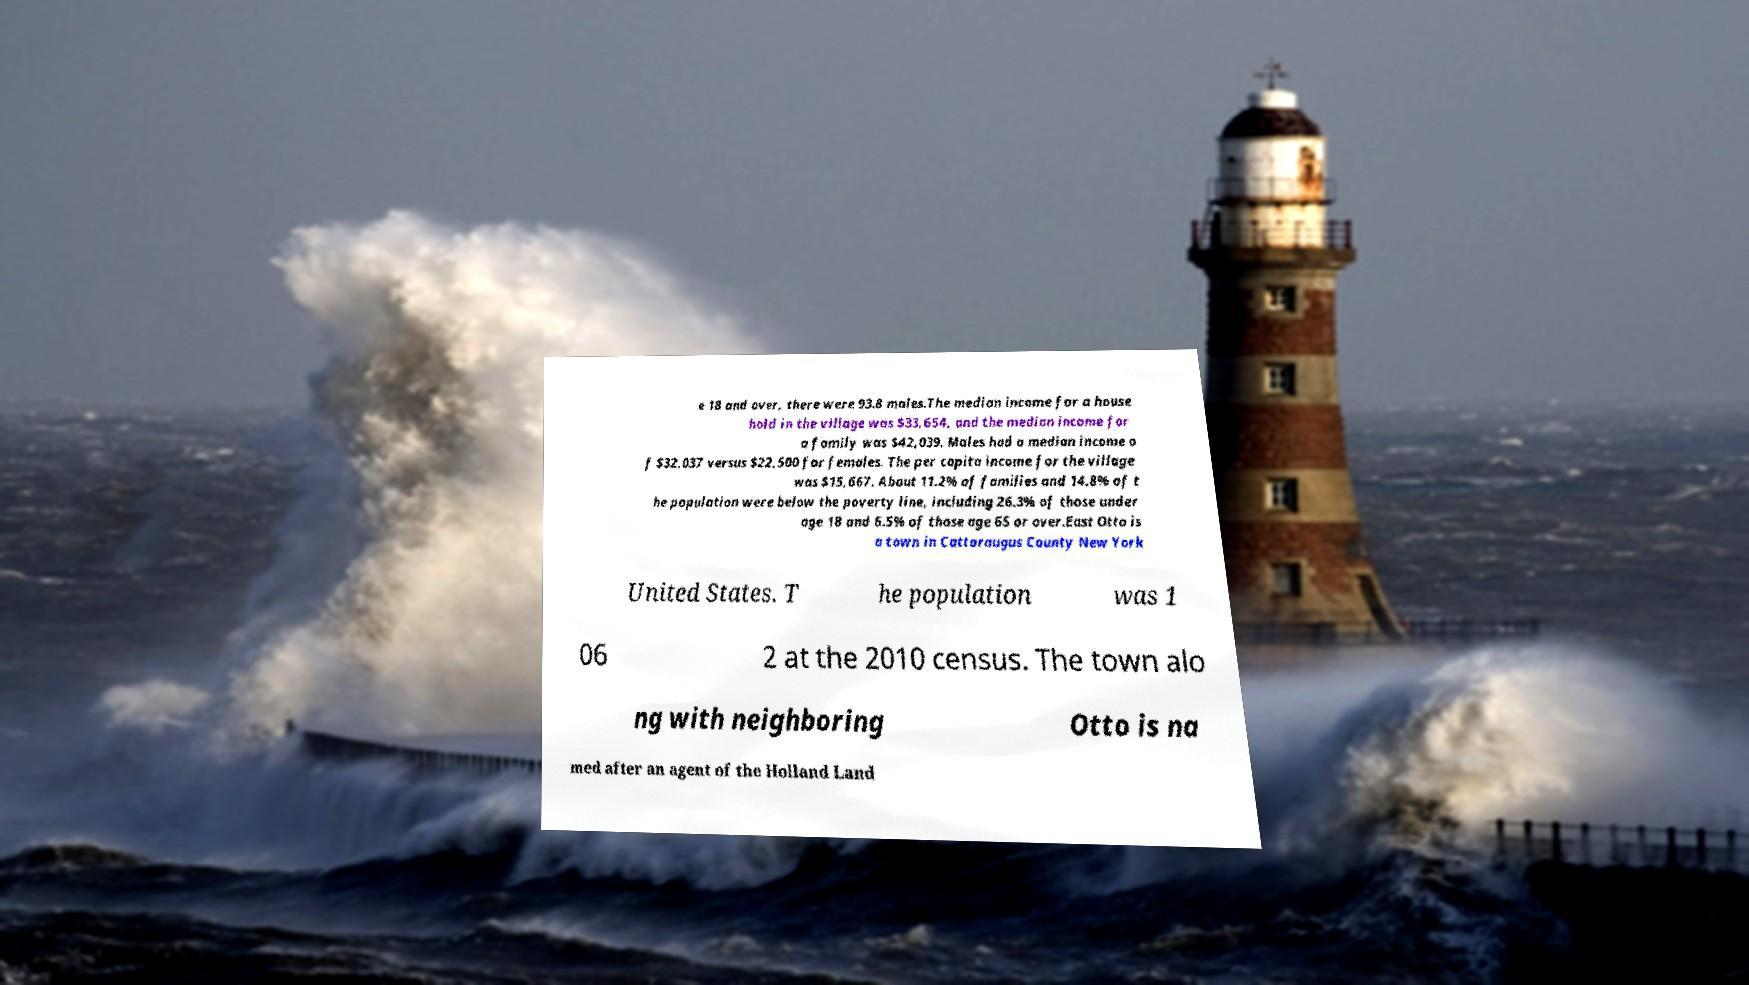There's text embedded in this image that I need extracted. Can you transcribe it verbatim? e 18 and over, there were 93.8 males.The median income for a house hold in the village was $33,654, and the median income for a family was $42,039. Males had a median income o f $32,037 versus $22,500 for females. The per capita income for the village was $15,667. About 11.2% of families and 14.8% of t he population were below the poverty line, including 26.3% of those under age 18 and 6.5% of those age 65 or over.East Otto is a town in Cattaraugus County New York United States. T he population was 1 06 2 at the 2010 census. The town alo ng with neighboring Otto is na med after an agent of the Holland Land 